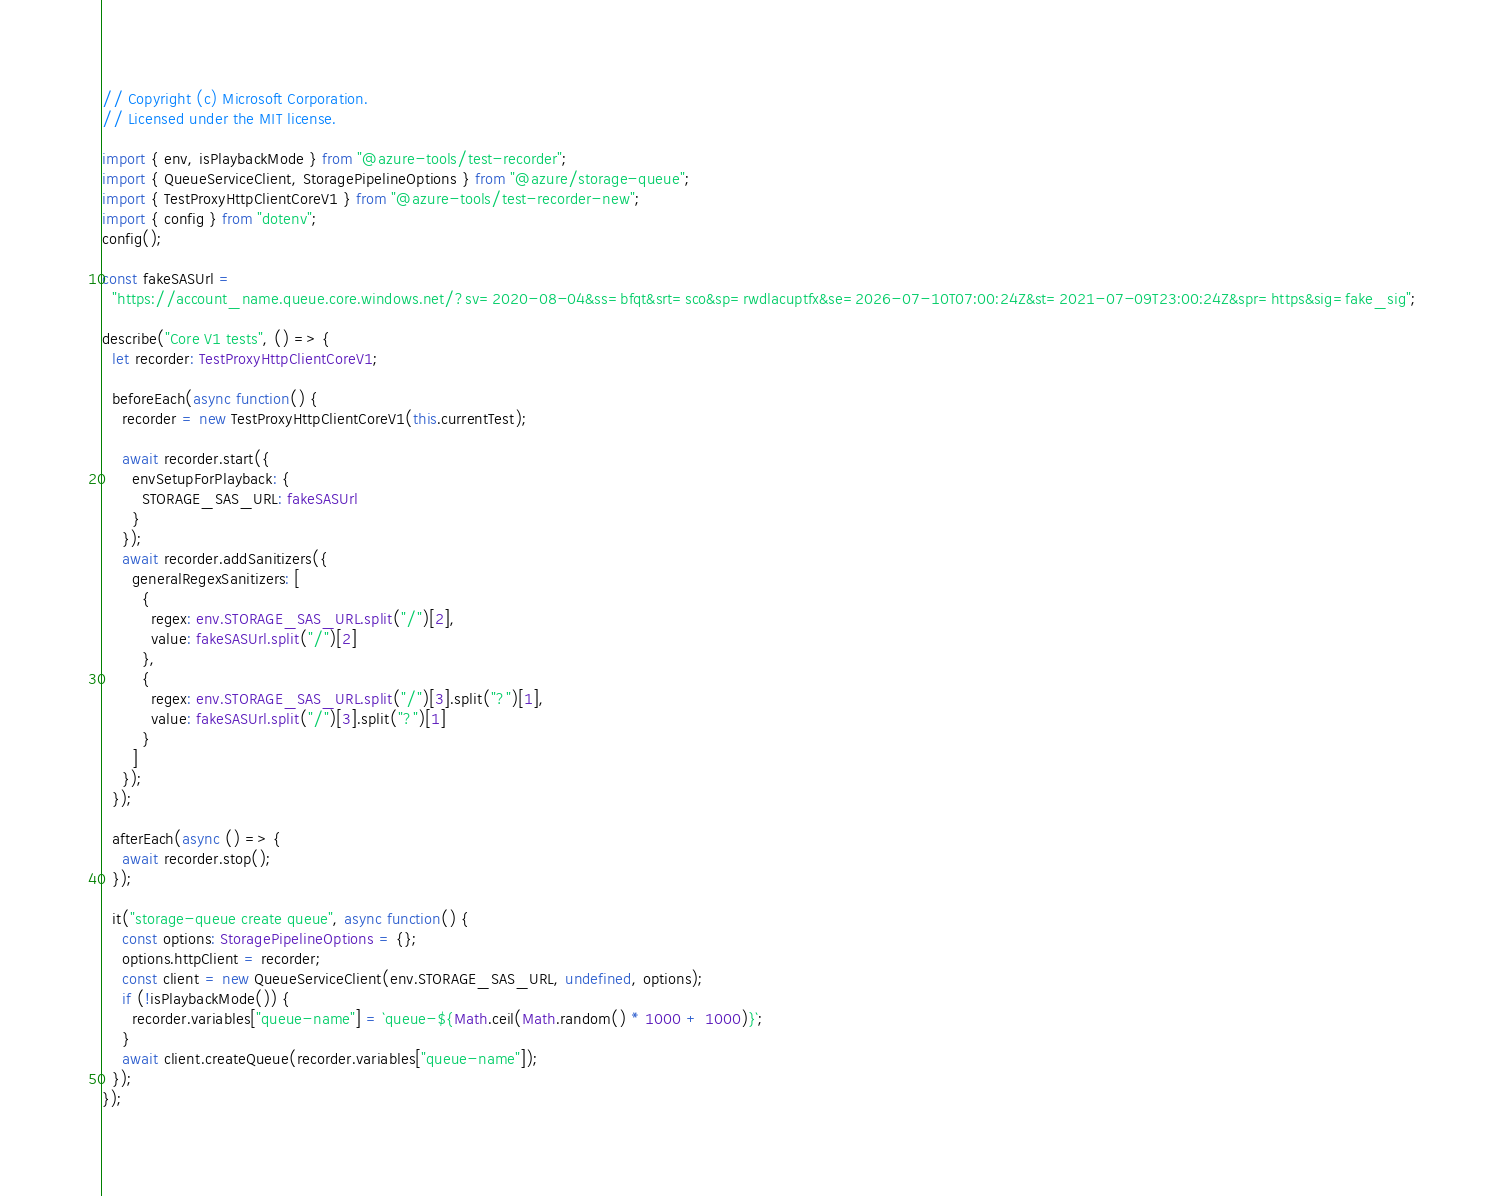<code> <loc_0><loc_0><loc_500><loc_500><_TypeScript_>// Copyright (c) Microsoft Corporation.
// Licensed under the MIT license.

import { env, isPlaybackMode } from "@azure-tools/test-recorder";
import { QueueServiceClient, StoragePipelineOptions } from "@azure/storage-queue";
import { TestProxyHttpClientCoreV1 } from "@azure-tools/test-recorder-new";
import { config } from "dotenv";
config();

const fakeSASUrl =
  "https://account_name.queue.core.windows.net/?sv=2020-08-04&ss=bfqt&srt=sco&sp=rwdlacuptfx&se=2026-07-10T07:00:24Z&st=2021-07-09T23:00:24Z&spr=https&sig=fake_sig";

describe("Core V1 tests", () => {
  let recorder: TestProxyHttpClientCoreV1;

  beforeEach(async function() {
    recorder = new TestProxyHttpClientCoreV1(this.currentTest);

    await recorder.start({
      envSetupForPlayback: {
        STORAGE_SAS_URL: fakeSASUrl
      }
    });
    await recorder.addSanitizers({
      generalRegexSanitizers: [
        {
          regex: env.STORAGE_SAS_URL.split("/")[2],
          value: fakeSASUrl.split("/")[2]
        },
        {
          regex: env.STORAGE_SAS_URL.split("/")[3].split("?")[1],
          value: fakeSASUrl.split("/")[3].split("?")[1]
        }
      ]
    });
  });

  afterEach(async () => {
    await recorder.stop();
  });

  it("storage-queue create queue", async function() {
    const options: StoragePipelineOptions = {};
    options.httpClient = recorder;
    const client = new QueueServiceClient(env.STORAGE_SAS_URL, undefined, options);
    if (!isPlaybackMode()) {
      recorder.variables["queue-name"] = `queue-${Math.ceil(Math.random() * 1000 + 1000)}`;
    }
    await client.createQueue(recorder.variables["queue-name"]);
  });
});
</code> 